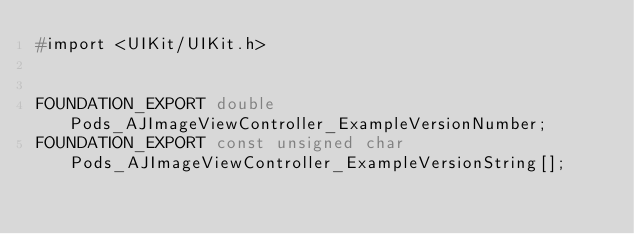<code> <loc_0><loc_0><loc_500><loc_500><_C_>#import <UIKit/UIKit.h>


FOUNDATION_EXPORT double Pods_AJImageViewController_ExampleVersionNumber;
FOUNDATION_EXPORT const unsigned char Pods_AJImageViewController_ExampleVersionString[];

</code> 